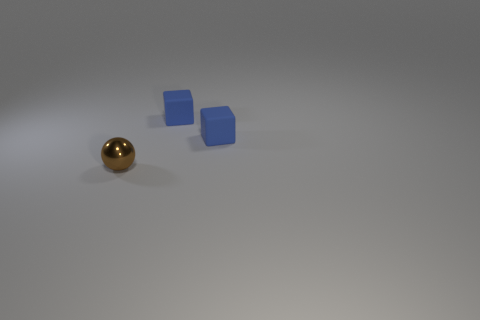Are there any other things that have the same shape as the tiny brown thing?
Your response must be concise. No. Are there any other yellow shiny things that have the same size as the metallic thing?
Your answer should be compact. No. What number of matte things are either balls or blue cubes?
Offer a very short reply. 2. How many tiny cubes have the same color as the tiny metallic sphere?
Provide a short and direct response. 0. How many things are blue cubes or tiny objects on the right side of the metal object?
Give a very brief answer. 2. Are there any other things that are the same material as the brown thing?
Give a very brief answer. No. How many green things are either metal balls or blocks?
Offer a very short reply. 0. What number of other objects are the same shape as the small shiny object?
Provide a short and direct response. 0. Are there more cubes that are right of the tiny metal thing than green rubber cylinders?
Offer a very short reply. Yes. What number of other objects are the same size as the metallic sphere?
Provide a succinct answer. 2. 